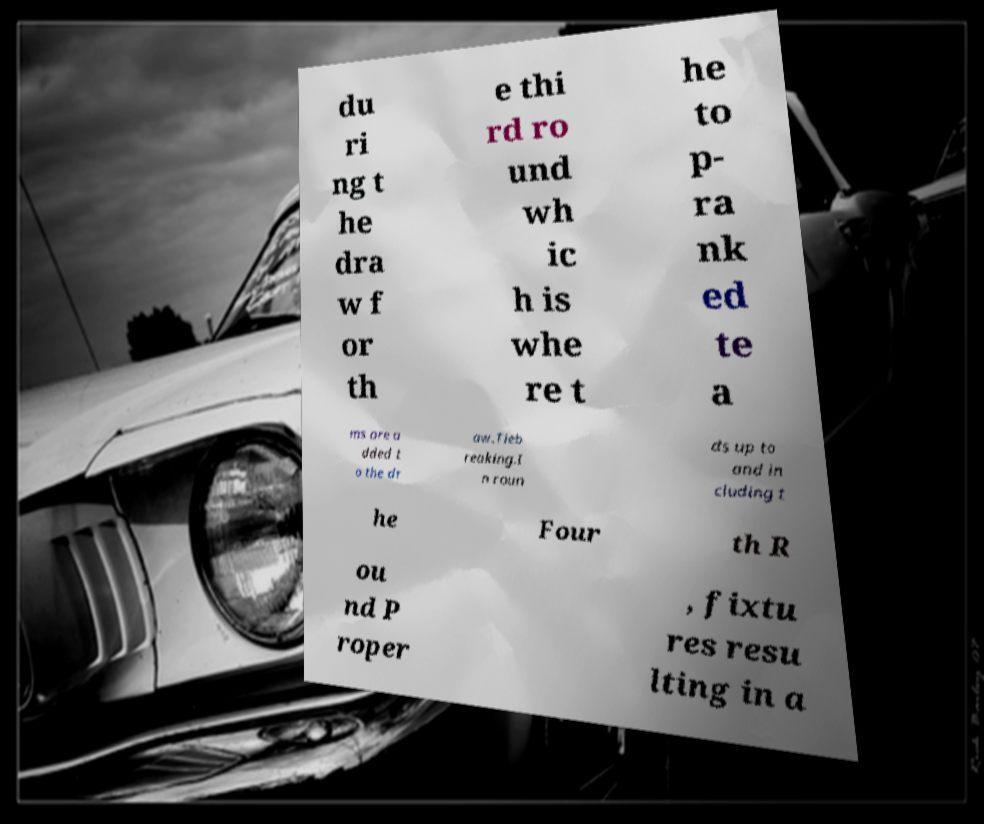Could you extract and type out the text from this image? du ri ng t he dra w f or th e thi rd ro und wh ic h is whe re t he to p- ra nk ed te a ms are a dded t o the dr aw.Tieb reaking.I n roun ds up to and in cluding t he Four th R ou nd P roper , fixtu res resu lting in a 